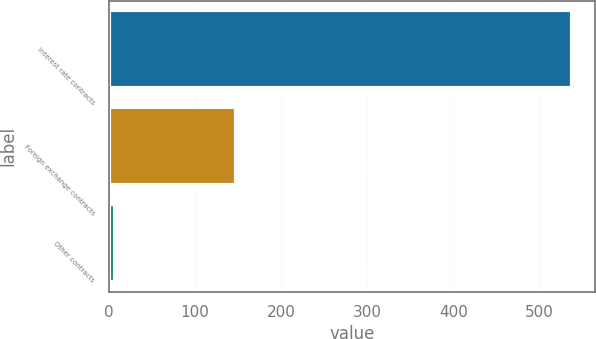<chart> <loc_0><loc_0><loc_500><loc_500><bar_chart><fcel>Interest rate contracts<fcel>Foreign exchange contracts<fcel>Other contracts<nl><fcel>538<fcel>148<fcel>7<nl></chart> 